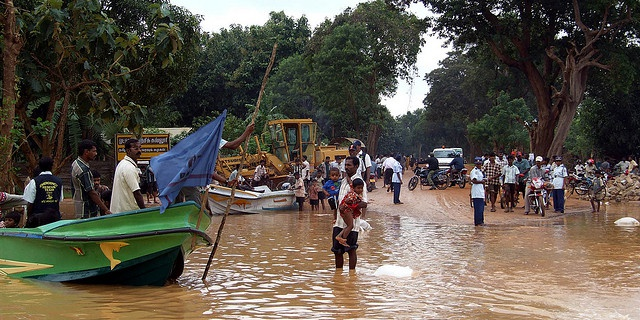Describe the objects in this image and their specific colors. I can see boat in black, darkgreen, and teal tones, people in black, gray, darkgray, and lightgray tones, people in black, maroon, darkgray, and lightgray tones, people in black, darkgray, gray, and olive tones, and people in black, darkgray, lightgray, and gray tones in this image. 